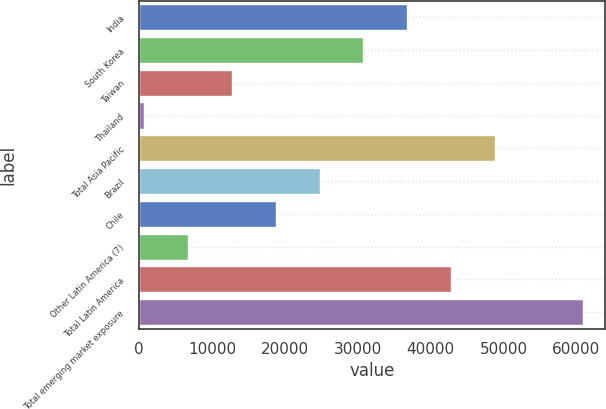<chart> <loc_0><loc_0><loc_500><loc_500><bar_chart><fcel>India<fcel>South Korea<fcel>Taiwan<fcel>Thailand<fcel>Total Asia Pacific<fcel>Brazil<fcel>Chile<fcel>Other Latin America (7)<fcel>Total Latin America<fcel>Total emerging market exposure<nl><fcel>36798.6<fcel>30773<fcel>12696.2<fcel>645<fcel>48849.8<fcel>24747.4<fcel>18721.8<fcel>6670.6<fcel>42824.2<fcel>60901<nl></chart> 